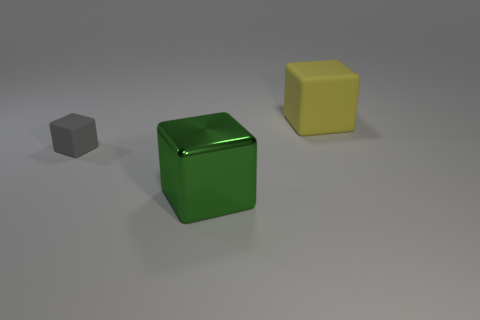Add 3 purple metal cubes. How many objects exist? 6 Subtract all large green metallic things. Subtract all big rubber things. How many objects are left? 1 Add 2 small gray things. How many small gray things are left? 3 Add 1 green metallic blocks. How many green metallic blocks exist? 2 Subtract 0 green cylinders. How many objects are left? 3 